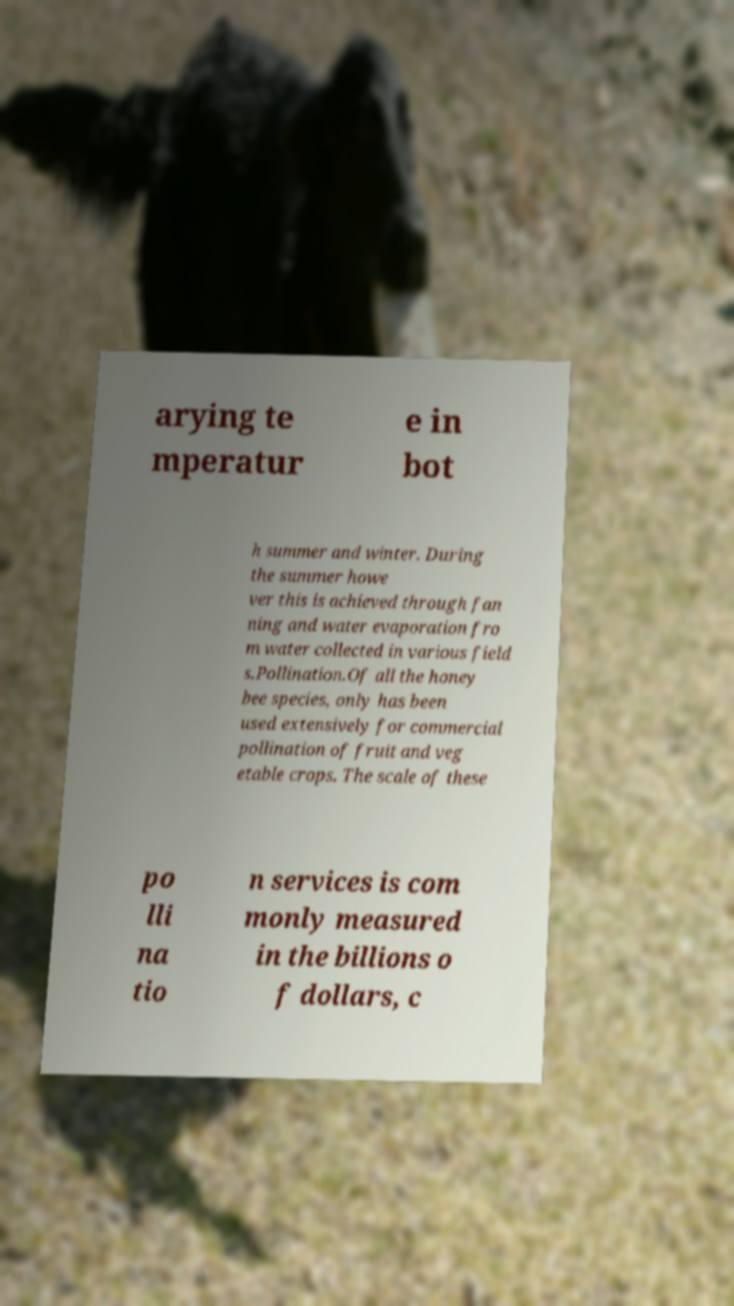Please identify and transcribe the text found in this image. arying te mperatur e in bot h summer and winter. During the summer howe ver this is achieved through fan ning and water evaporation fro m water collected in various field s.Pollination.Of all the honey bee species, only has been used extensively for commercial pollination of fruit and veg etable crops. The scale of these po lli na tio n services is com monly measured in the billions o f dollars, c 